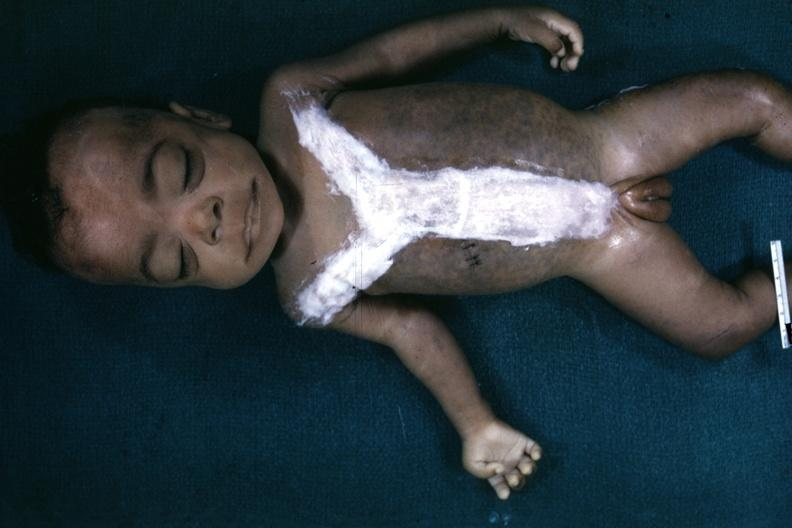what is present?
Answer the question using a single word or phrase. Downs syndrome 